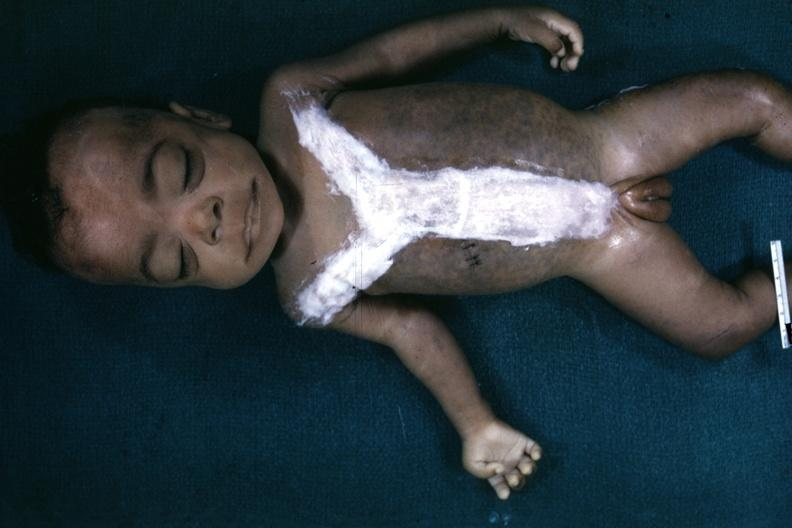what is present?
Answer the question using a single word or phrase. Downs syndrome 